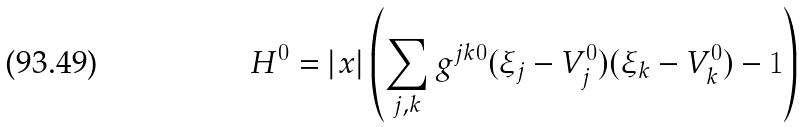Convert formula to latex. <formula><loc_0><loc_0><loc_500><loc_500>H ^ { 0 } = | x | \left ( \sum _ { j , k } g ^ { j k 0 } ( \xi _ { j } - V ^ { 0 } _ { j } ) ( \xi _ { k } - V ^ { 0 } _ { k } ) - 1 \right )</formula> 